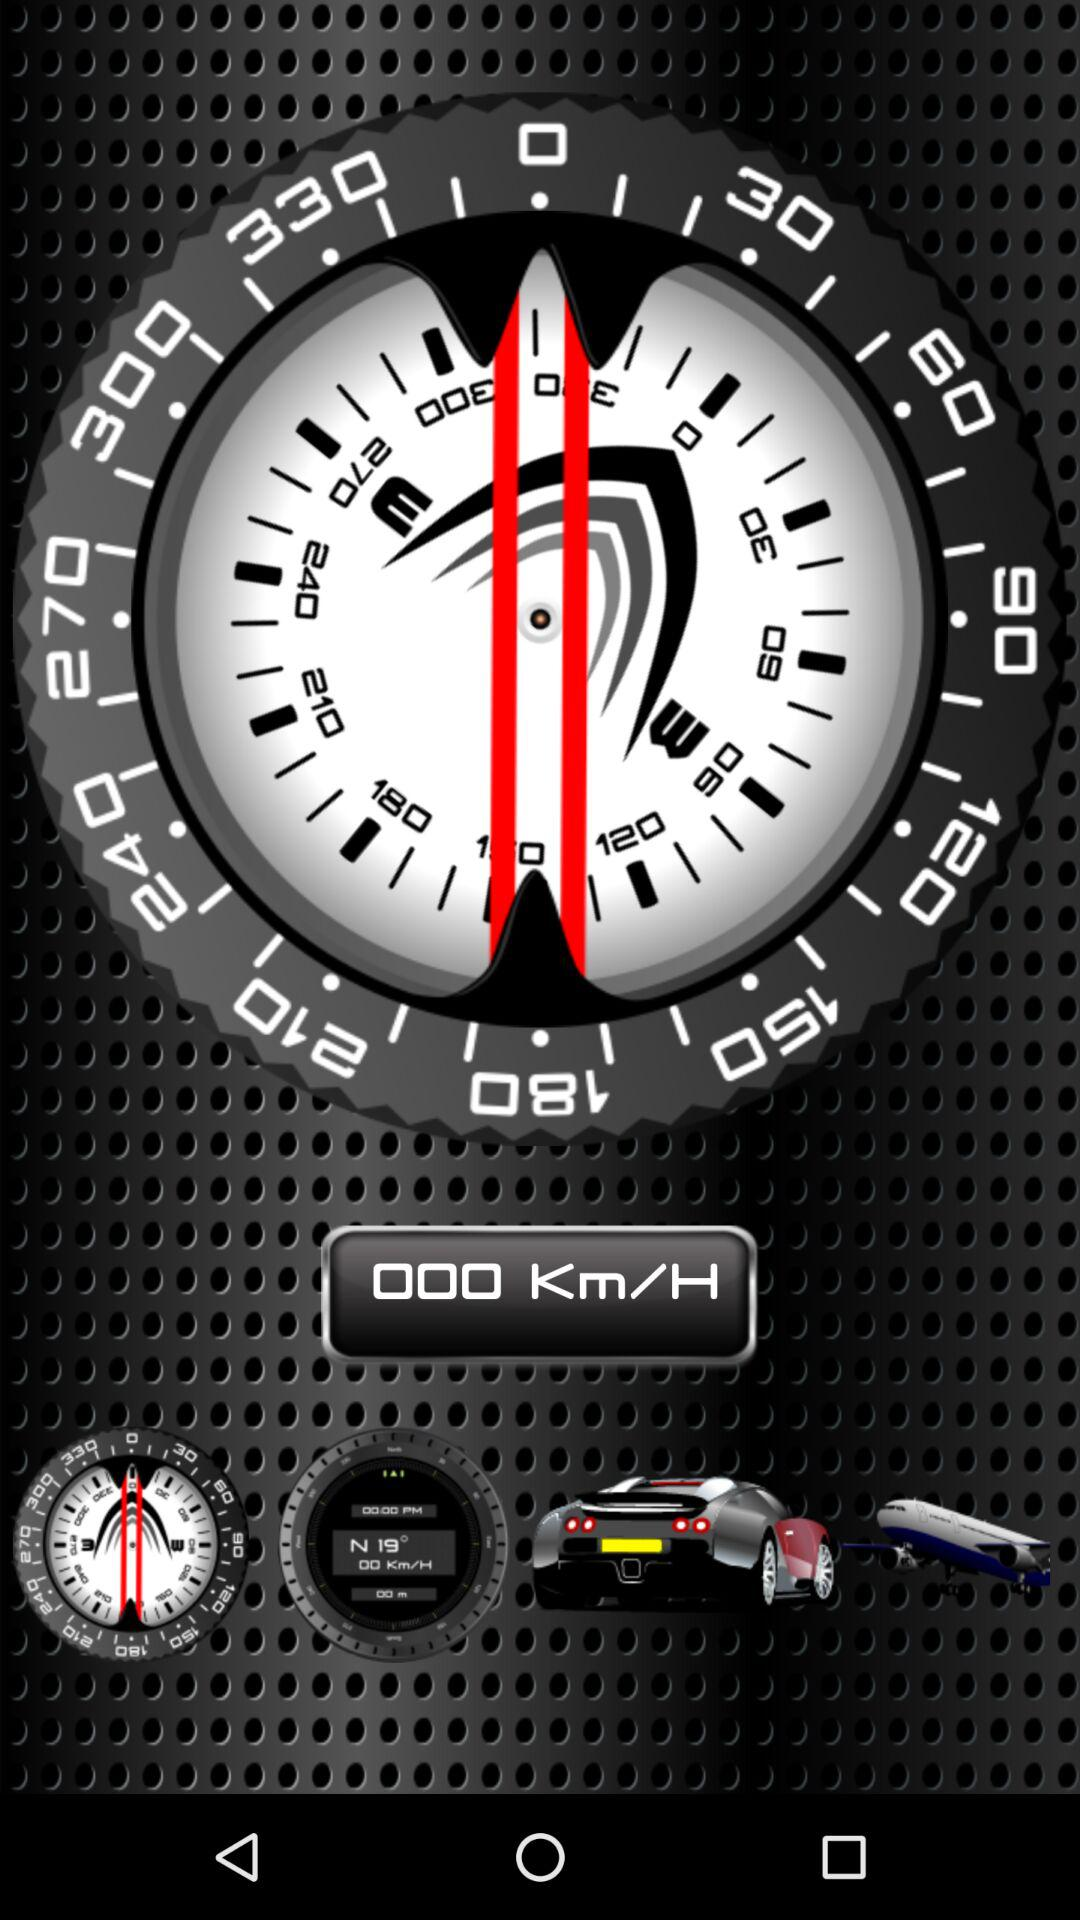What is the name of the application?
When the provided information is insufficient, respond with <no answer>. <no answer> 